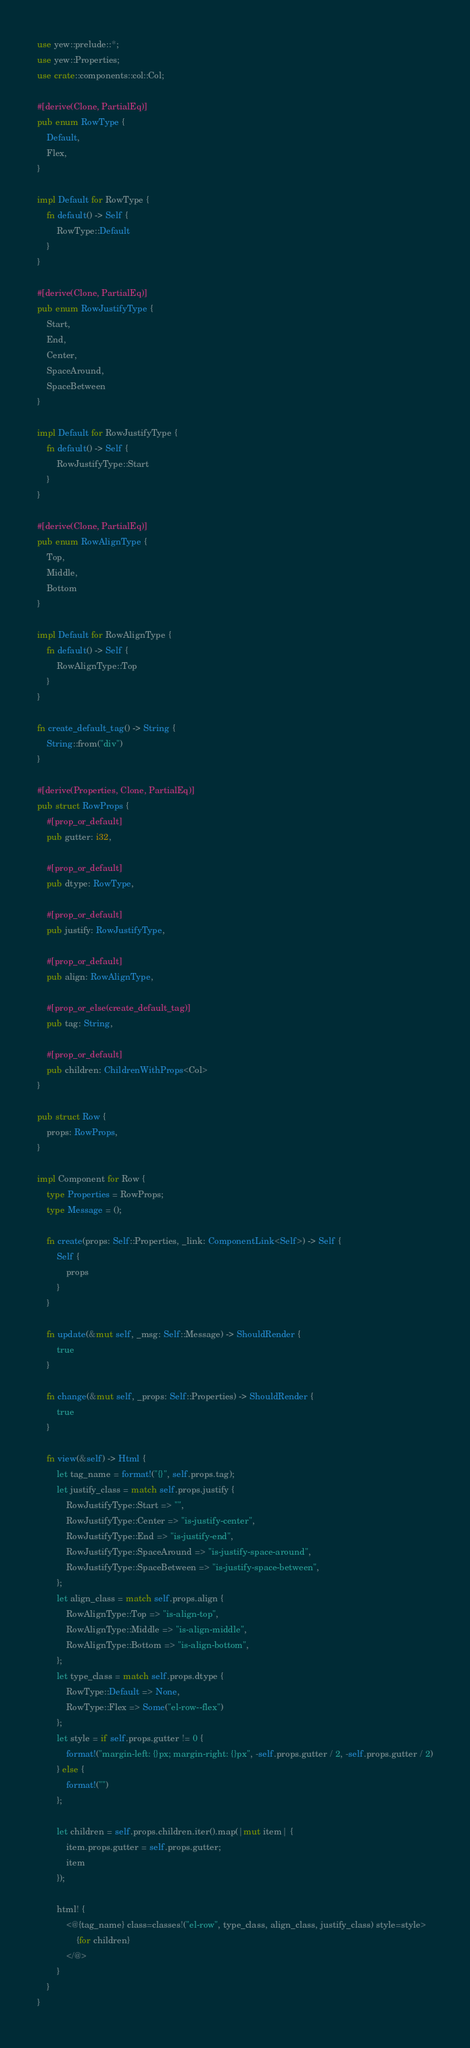Convert code to text. <code><loc_0><loc_0><loc_500><loc_500><_Rust_>use yew::prelude::*;
use yew::Properties;
use crate::components::col::Col;

#[derive(Clone, PartialEq)]
pub enum RowType {
    Default,
    Flex,
}

impl Default for RowType {
    fn default() -> Self {
        RowType::Default
    }
}

#[derive(Clone, PartialEq)]
pub enum RowJustifyType {
    Start,
    End,
    Center,
    SpaceAround,
    SpaceBetween
}

impl Default for RowJustifyType {
    fn default() -> Self {
        RowJustifyType::Start
    }
}

#[derive(Clone, PartialEq)]
pub enum RowAlignType {
    Top,
    Middle,
    Bottom
}

impl Default for RowAlignType {
    fn default() -> Self {
        RowAlignType::Top
    }
}

fn create_default_tag() -> String {
    String::from("div")
}

#[derive(Properties, Clone, PartialEq)]
pub struct RowProps {
    #[prop_or_default]
    pub gutter: i32,

    #[prop_or_default]
    pub dtype: RowType,

    #[prop_or_default]
    pub justify: RowJustifyType,

    #[prop_or_default]
    pub align: RowAlignType,

    #[prop_or_else(create_default_tag)]
    pub tag: String,

    #[prop_or_default]
    pub children: ChildrenWithProps<Col>
}

pub struct Row {
    props: RowProps,
}

impl Component for Row {
    type Properties = RowProps;
    type Message = ();

    fn create(props: Self::Properties, _link: ComponentLink<Self>) -> Self {
        Self {
            props
        }
    }

    fn update(&mut self, _msg: Self::Message) -> ShouldRender {
        true
    }

    fn change(&mut self, _props: Self::Properties) -> ShouldRender {
        true
    }

    fn view(&self) -> Html {
        let tag_name = format!("{}", self.props.tag);
        let justify_class = match self.props.justify {
            RowJustifyType::Start => "",
            RowJustifyType::Center => "is-justify-center",
            RowJustifyType::End => "is-justify-end",
            RowJustifyType::SpaceAround => "is-justify-space-around",
            RowJustifyType::SpaceBetween => "is-justify-space-between",
        };
        let align_class = match self.props.align {
            RowAlignType::Top => "is-align-top",
            RowAlignType::Middle => "is-align-middle",
            RowAlignType::Bottom => "is-align-bottom",
        };
        let type_class = match self.props.dtype {
            RowType::Default => None,
            RowType::Flex => Some("el-row--flex")
        };
        let style = if self.props.gutter != 0 {
            format!("margin-left: {}px; margin-right: {}px", -self.props.gutter / 2, -self.props.gutter / 2)
        } else {
            format!("")
        };

        let children = self.props.children.iter().map(|mut item| {
            item.props.gutter = self.props.gutter;
            item
        });

        html! {
            <@{tag_name} class=classes!("el-row", type_class, align_class, justify_class) style=style>
                {for children}
            </@>
        }
    }
}
</code> 